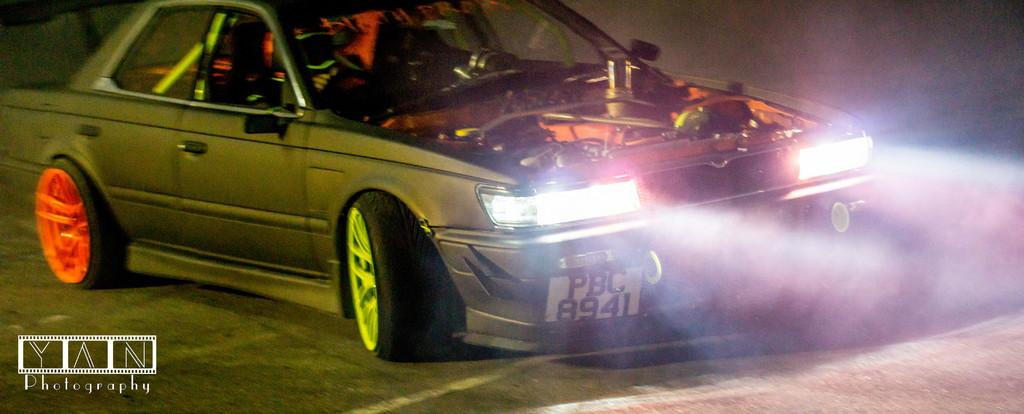What is the main subject of the image? The main subject of the image is a car. What features can be seen on the car? The car has lights, an engine, and different color wheel rims. What is visible in the background of the image? There is a road visible in the image. Is there any additional information or branding present in the image? Yes, there is a watermark in the image. Can you tell me how many masks are hanging from the car's rearview mirror in the image? There are no masks present in the image; the focus is on the car and its features. 